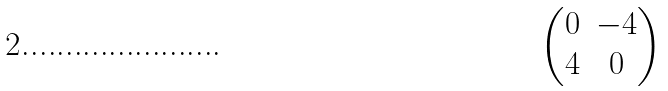Convert formula to latex. <formula><loc_0><loc_0><loc_500><loc_500>\begin{pmatrix} 0 & - 4 \\ 4 & 0 \end{pmatrix}</formula> 